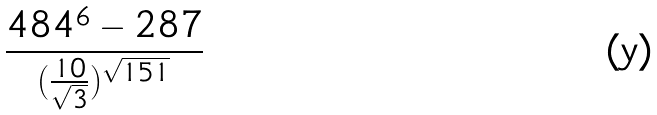Convert formula to latex. <formula><loc_0><loc_0><loc_500><loc_500>\frac { 4 8 4 ^ { 6 } - 2 8 7 } { ( \frac { 1 0 } { \sqrt { 3 } } ) ^ { \sqrt { 1 5 1 } } }</formula> 